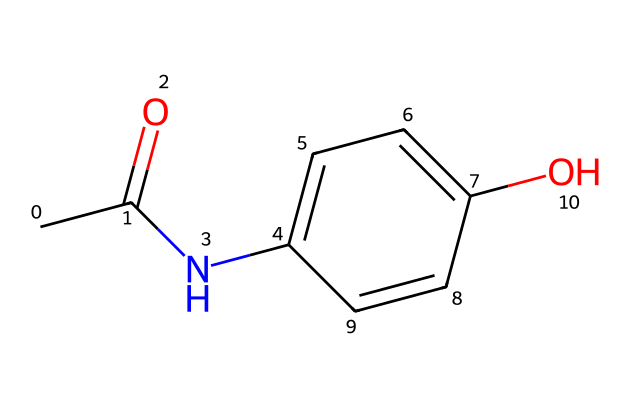How many carbon atoms are in acetaminophen? The SMILES structure shows that there are six carbon atoms represented in the main and side chains of the molecule. Counting the 'C' symbols in the representation confirms this.
Answer: six What functional groups are present in acetaminophen? In the SMILES, the presence of 'C(=O)' indicates a carbonyl group (ketone), 'N' indicates an amine group, and 'OH' indicates a hydroxyl group. Thus, these functional groups include a carbonyl, amine, and hydroxyl.
Answer: carbonyl, amine, hydroxyl What is the molecular formula of acetaminophen? By analyzing the components of the SMILES, we identify 8 carbon atoms, 9 hydrogen atoms, 1 nitrogen atom, and 1 oxygen atom. This corresponds to the molecular formula C8H9NO2.
Answer: C8H9NO2 What type of drug is acetaminophen classified as? Acetaminophen is primarily classified as an analgesic and antipyretic, which refers to its use in pain relief and fever reduction. This classification is consistent with its chemical structure and properties.
Answer: analgesic and antipyretic Why does acetaminophen have pain-relieving properties? The structure of acetaminophen includes an amine group and a carbonyl group, which are known to interact with pain pathways in the body. These functional groups help inhibit the production of prostaglandins that mediate pain.
Answer: it inhibits prostaglandin production What type of bonding is primarily found in acetaminophen? The chemical structure indicates that there are covalent bonds forming between the carbon, hydrogen, nitrogen, and oxygen atoms, which is typical for organic compounds. Hence, acetaminophen is composed mainly of covalent bonds.
Answer: covalent bonds How does the presence of the hydroxyl group affect acetaminophen's function? The hydroxyl group contributes to the overall polarity of acetaminophen, enhancing its solubility in the body and affecting how it interacts with biological receptors, making it effective as a medication.
Answer: enhances solubility and receptor interaction 